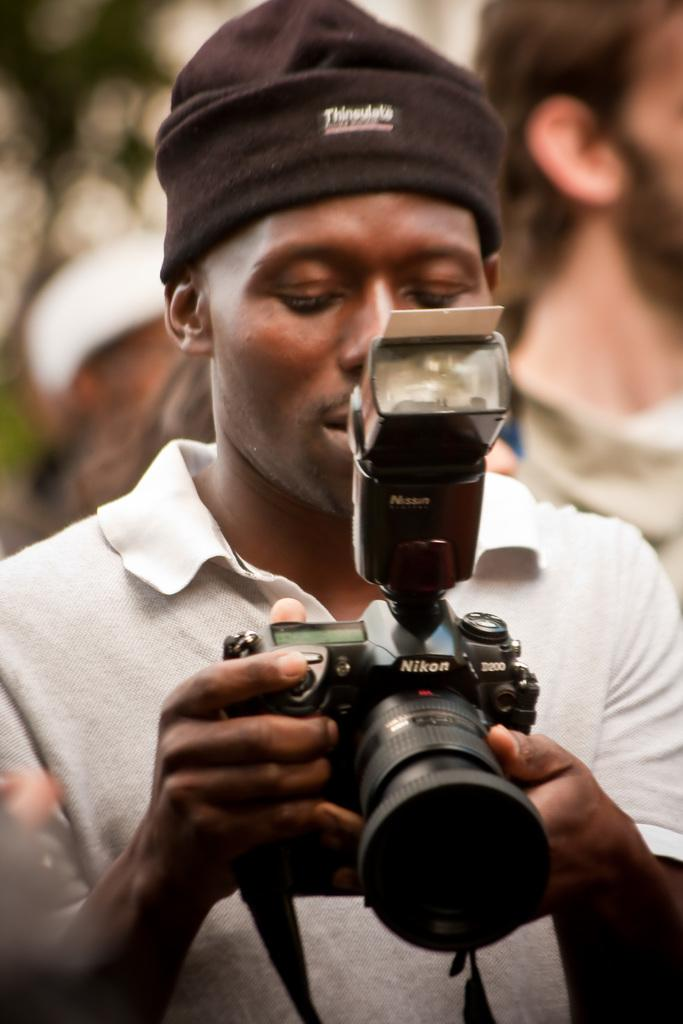Provide a one-sentence caption for the provided image. A young man holding a Nikon digital camera. 